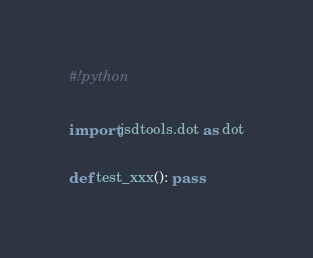Convert code to text. <code><loc_0><loc_0><loc_500><loc_500><_Python_>#!python

import jsdtools.dot as dot

def test_xxx(): pass
</code> 